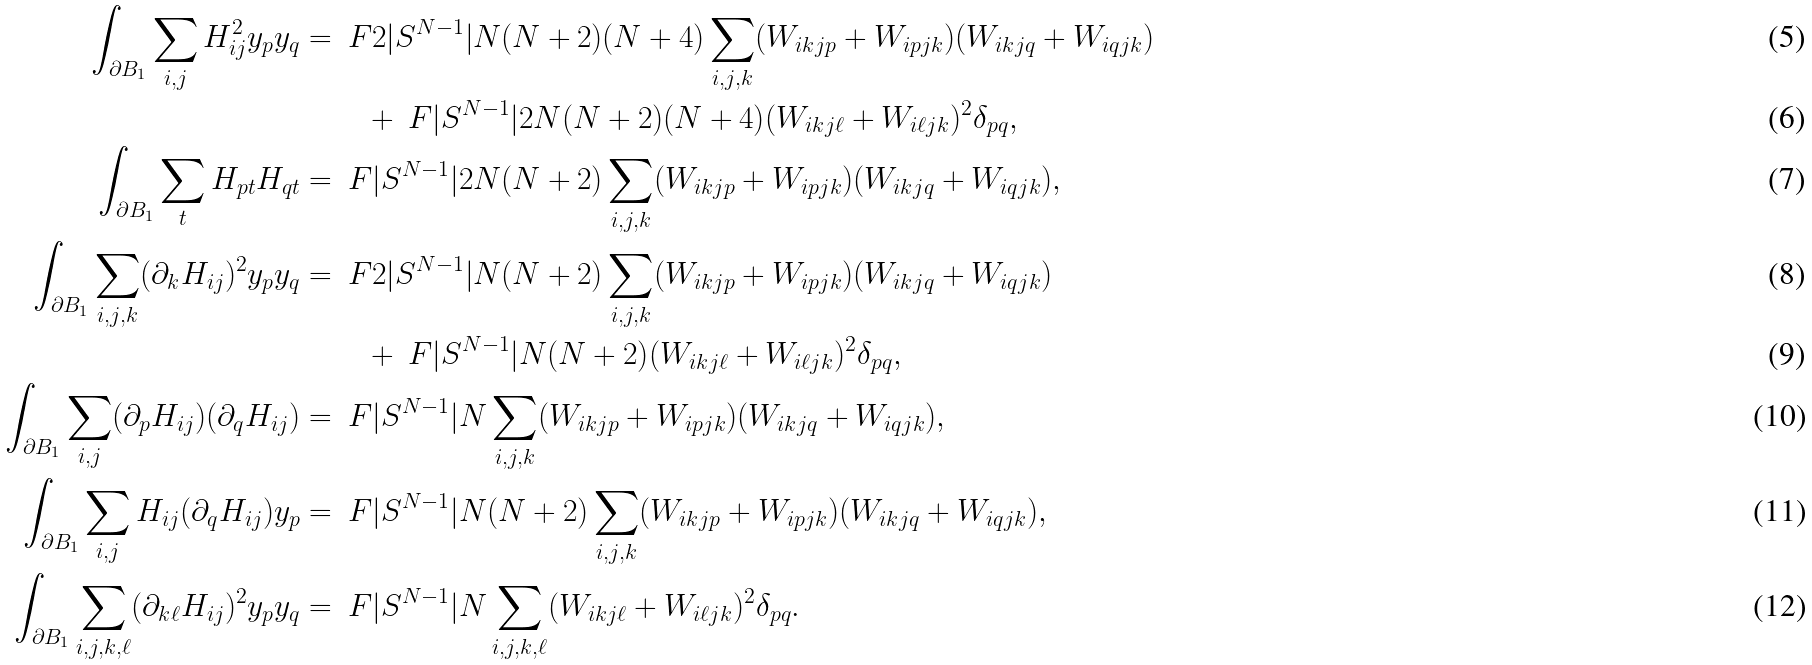Convert formula to latex. <formula><loc_0><loc_0><loc_500><loc_500>\int _ { \partial B _ { 1 } } \sum _ { i , j } H _ { i j } ^ { 2 } y _ { p } y _ { q } = & \ \ F { 2 | S ^ { N - 1 } | } { N ( N + 2 ) ( N + 4 ) } \sum _ { i , j , k } ( W _ { i k j p } + W _ { i p j k } ) ( W _ { i k j q } + W _ { i q j k } ) \\ & \quad + \ F { | S ^ { N - 1 } | } { 2 N ( N + 2 ) ( N + 4 ) } ( W _ { i k j \ell } + W _ { i \ell j k } ) ^ { 2 } \delta _ { p q } , \\ \int _ { \partial B _ { 1 } } \sum _ { t } H _ { p t } H _ { q t } = & \ \ F { | S ^ { N - 1 } | } { 2 N ( N + 2 ) } \sum _ { i , j , k } ( W _ { i k j p } + W _ { i p j k } ) ( W _ { i k j q } + W _ { i q j k } ) , \\ \int _ { \partial B _ { 1 } } \sum _ { i , j , k } ( \partial _ { k } H _ { i j } ) ^ { 2 } y _ { p } y _ { q } = & \ \ F { 2 | S ^ { N - 1 } | } { N ( N + 2 ) } \sum _ { i , j , k } ( W _ { i k j p } + W _ { i p j k } ) ( W _ { i k j q } + W _ { i q j k } ) \\ & \quad + \ F { | S ^ { N - 1 } | } { N ( N + 2 ) } ( W _ { i k j \ell } + W _ { i \ell j k } ) ^ { 2 } \delta _ { p q } , \\ \int _ { \partial B _ { 1 } } \sum _ { i , j } ( \partial _ { p } H _ { i j } ) ( \partial _ { q } H _ { i j } ) = & \ \ F { | S ^ { N - 1 } | } { N } \sum _ { i , j , k } ( W _ { i k j p } + W _ { i p j k } ) ( W _ { i k j q } + W _ { i q j k } ) , \\ \int _ { \partial B _ { 1 } } \sum _ { i , j } H _ { i j } ( \partial _ { q } H _ { i j } ) y _ { p } = & \ \ F { | S ^ { N - 1 } | } { N ( N + 2 ) } \sum _ { i , j , k } ( W _ { i k j p } + W _ { i p j k } ) ( W _ { i k j q } + W _ { i q j k } ) , \\ \int _ { \partial B _ { 1 } } \sum _ { i , j , k , \ell } ( \partial _ { k \ell } H _ { i j } ) ^ { 2 } y _ { p } y _ { q } = & \ \ F { | S ^ { N - 1 } | } { N } \sum _ { i , j , k , \ell } ( W _ { i k j \ell } + W _ { i \ell j k } ) ^ { 2 } \delta _ { p q } .</formula> 